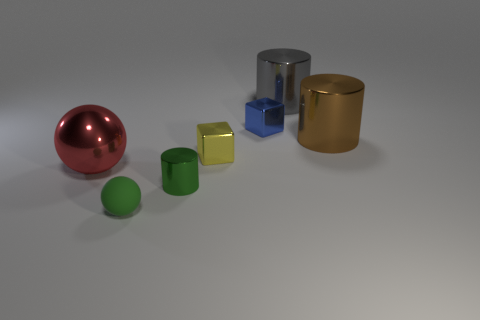Add 2 large brown shiny objects. How many objects exist? 9 Subtract all cylinders. How many objects are left? 4 Add 3 big gray objects. How many big gray objects are left? 4 Add 6 large green rubber blocks. How many large green rubber blocks exist? 6 Subtract 0 brown blocks. How many objects are left? 7 Subtract all large brown things. Subtract all blue metallic cubes. How many objects are left? 5 